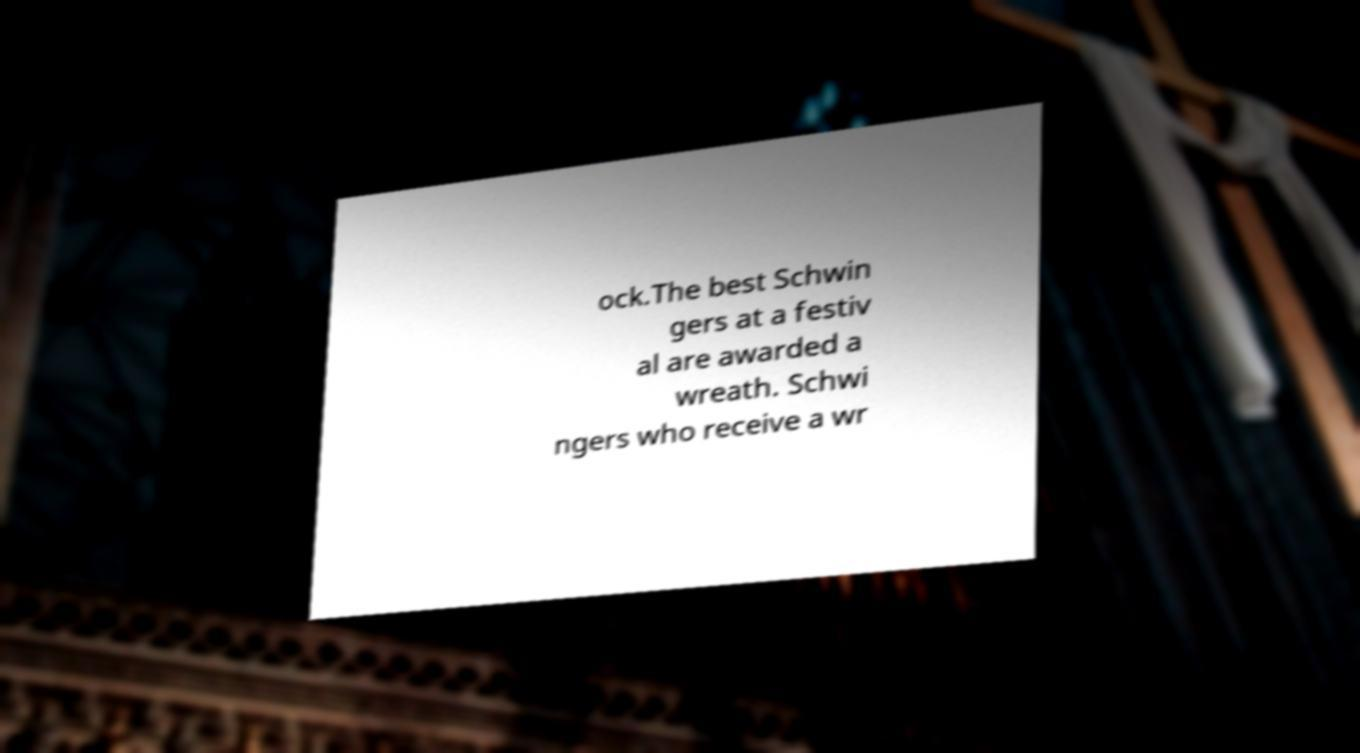What messages or text are displayed in this image? I need them in a readable, typed format. ock.The best Schwin gers at a festiv al are awarded a wreath. Schwi ngers who receive a wr 